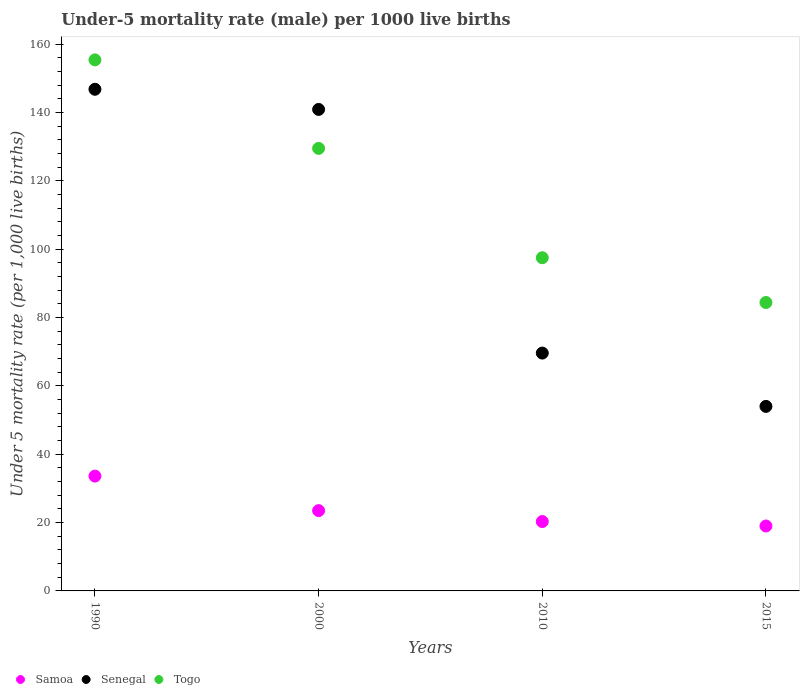What is the under-five mortality rate in Senegal in 2010?
Ensure brevity in your answer.  69.6. Across all years, what is the maximum under-five mortality rate in Senegal?
Give a very brief answer. 146.8. In which year was the under-five mortality rate in Togo maximum?
Your answer should be very brief. 1990. In which year was the under-five mortality rate in Senegal minimum?
Your answer should be very brief. 2015. What is the total under-five mortality rate in Togo in the graph?
Provide a short and direct response. 466.8. What is the difference between the under-five mortality rate in Samoa in 1990 and that in 2015?
Your answer should be compact. 14.6. What is the difference between the under-five mortality rate in Togo in 2015 and the under-five mortality rate in Samoa in 1990?
Keep it short and to the point. 50.8. What is the average under-five mortality rate in Togo per year?
Provide a succinct answer. 116.7. In the year 2010, what is the difference between the under-five mortality rate in Samoa and under-five mortality rate in Togo?
Your answer should be compact. -77.2. What is the ratio of the under-five mortality rate in Togo in 1990 to that in 2010?
Offer a terse response. 1.59. Is the difference between the under-five mortality rate in Samoa in 1990 and 2010 greater than the difference between the under-five mortality rate in Togo in 1990 and 2010?
Ensure brevity in your answer.  No. What is the difference between the highest and the second highest under-five mortality rate in Samoa?
Keep it short and to the point. 10.1. What is the difference between the highest and the lowest under-five mortality rate in Samoa?
Keep it short and to the point. 14.6. In how many years, is the under-five mortality rate in Samoa greater than the average under-five mortality rate in Samoa taken over all years?
Your answer should be compact. 1. Is the sum of the under-five mortality rate in Togo in 1990 and 2000 greater than the maximum under-five mortality rate in Senegal across all years?
Give a very brief answer. Yes. Is it the case that in every year, the sum of the under-five mortality rate in Senegal and under-five mortality rate in Samoa  is greater than the under-five mortality rate in Togo?
Provide a succinct answer. No. Does the under-five mortality rate in Samoa monotonically increase over the years?
Ensure brevity in your answer.  No. Is the under-five mortality rate in Samoa strictly greater than the under-five mortality rate in Senegal over the years?
Offer a very short reply. No. How many years are there in the graph?
Your response must be concise. 4. Does the graph contain any zero values?
Provide a succinct answer. No. Does the graph contain grids?
Offer a terse response. No. Where does the legend appear in the graph?
Make the answer very short. Bottom left. What is the title of the graph?
Provide a short and direct response. Under-5 mortality rate (male) per 1000 live births. Does "Ghana" appear as one of the legend labels in the graph?
Provide a succinct answer. No. What is the label or title of the X-axis?
Offer a very short reply. Years. What is the label or title of the Y-axis?
Offer a very short reply. Under 5 mortality rate (per 1,0 live births). What is the Under 5 mortality rate (per 1,000 live births) in Samoa in 1990?
Your answer should be very brief. 33.6. What is the Under 5 mortality rate (per 1,000 live births) of Senegal in 1990?
Ensure brevity in your answer.  146.8. What is the Under 5 mortality rate (per 1,000 live births) in Togo in 1990?
Your answer should be very brief. 155.4. What is the Under 5 mortality rate (per 1,000 live births) in Samoa in 2000?
Provide a short and direct response. 23.5. What is the Under 5 mortality rate (per 1,000 live births) of Senegal in 2000?
Your response must be concise. 140.9. What is the Under 5 mortality rate (per 1,000 live births) in Togo in 2000?
Provide a short and direct response. 129.5. What is the Under 5 mortality rate (per 1,000 live births) in Samoa in 2010?
Offer a terse response. 20.3. What is the Under 5 mortality rate (per 1,000 live births) of Senegal in 2010?
Make the answer very short. 69.6. What is the Under 5 mortality rate (per 1,000 live births) of Togo in 2010?
Your answer should be very brief. 97.5. What is the Under 5 mortality rate (per 1,000 live births) in Senegal in 2015?
Your answer should be compact. 54. What is the Under 5 mortality rate (per 1,000 live births) of Togo in 2015?
Your response must be concise. 84.4. Across all years, what is the maximum Under 5 mortality rate (per 1,000 live births) in Samoa?
Offer a very short reply. 33.6. Across all years, what is the maximum Under 5 mortality rate (per 1,000 live births) in Senegal?
Keep it short and to the point. 146.8. Across all years, what is the maximum Under 5 mortality rate (per 1,000 live births) of Togo?
Keep it short and to the point. 155.4. Across all years, what is the minimum Under 5 mortality rate (per 1,000 live births) of Togo?
Your answer should be very brief. 84.4. What is the total Under 5 mortality rate (per 1,000 live births) in Samoa in the graph?
Offer a terse response. 96.4. What is the total Under 5 mortality rate (per 1,000 live births) of Senegal in the graph?
Provide a succinct answer. 411.3. What is the total Under 5 mortality rate (per 1,000 live births) of Togo in the graph?
Offer a terse response. 466.8. What is the difference between the Under 5 mortality rate (per 1,000 live births) in Samoa in 1990 and that in 2000?
Provide a short and direct response. 10.1. What is the difference between the Under 5 mortality rate (per 1,000 live births) in Senegal in 1990 and that in 2000?
Your response must be concise. 5.9. What is the difference between the Under 5 mortality rate (per 1,000 live births) of Togo in 1990 and that in 2000?
Ensure brevity in your answer.  25.9. What is the difference between the Under 5 mortality rate (per 1,000 live births) in Senegal in 1990 and that in 2010?
Make the answer very short. 77.2. What is the difference between the Under 5 mortality rate (per 1,000 live births) of Togo in 1990 and that in 2010?
Give a very brief answer. 57.9. What is the difference between the Under 5 mortality rate (per 1,000 live births) in Samoa in 1990 and that in 2015?
Keep it short and to the point. 14.6. What is the difference between the Under 5 mortality rate (per 1,000 live births) in Senegal in 1990 and that in 2015?
Your answer should be compact. 92.8. What is the difference between the Under 5 mortality rate (per 1,000 live births) of Togo in 1990 and that in 2015?
Offer a very short reply. 71. What is the difference between the Under 5 mortality rate (per 1,000 live births) in Samoa in 2000 and that in 2010?
Keep it short and to the point. 3.2. What is the difference between the Under 5 mortality rate (per 1,000 live births) in Senegal in 2000 and that in 2010?
Your response must be concise. 71.3. What is the difference between the Under 5 mortality rate (per 1,000 live births) in Togo in 2000 and that in 2010?
Your answer should be very brief. 32. What is the difference between the Under 5 mortality rate (per 1,000 live births) of Samoa in 2000 and that in 2015?
Your answer should be compact. 4.5. What is the difference between the Under 5 mortality rate (per 1,000 live births) of Senegal in 2000 and that in 2015?
Give a very brief answer. 86.9. What is the difference between the Under 5 mortality rate (per 1,000 live births) in Togo in 2000 and that in 2015?
Keep it short and to the point. 45.1. What is the difference between the Under 5 mortality rate (per 1,000 live births) in Samoa in 2010 and that in 2015?
Provide a succinct answer. 1.3. What is the difference between the Under 5 mortality rate (per 1,000 live births) of Senegal in 2010 and that in 2015?
Keep it short and to the point. 15.6. What is the difference between the Under 5 mortality rate (per 1,000 live births) of Togo in 2010 and that in 2015?
Your answer should be compact. 13.1. What is the difference between the Under 5 mortality rate (per 1,000 live births) of Samoa in 1990 and the Under 5 mortality rate (per 1,000 live births) of Senegal in 2000?
Offer a very short reply. -107.3. What is the difference between the Under 5 mortality rate (per 1,000 live births) of Samoa in 1990 and the Under 5 mortality rate (per 1,000 live births) of Togo in 2000?
Your answer should be very brief. -95.9. What is the difference between the Under 5 mortality rate (per 1,000 live births) of Senegal in 1990 and the Under 5 mortality rate (per 1,000 live births) of Togo in 2000?
Offer a very short reply. 17.3. What is the difference between the Under 5 mortality rate (per 1,000 live births) of Samoa in 1990 and the Under 5 mortality rate (per 1,000 live births) of Senegal in 2010?
Provide a short and direct response. -36. What is the difference between the Under 5 mortality rate (per 1,000 live births) in Samoa in 1990 and the Under 5 mortality rate (per 1,000 live births) in Togo in 2010?
Your answer should be compact. -63.9. What is the difference between the Under 5 mortality rate (per 1,000 live births) of Senegal in 1990 and the Under 5 mortality rate (per 1,000 live births) of Togo in 2010?
Provide a short and direct response. 49.3. What is the difference between the Under 5 mortality rate (per 1,000 live births) of Samoa in 1990 and the Under 5 mortality rate (per 1,000 live births) of Senegal in 2015?
Ensure brevity in your answer.  -20.4. What is the difference between the Under 5 mortality rate (per 1,000 live births) of Samoa in 1990 and the Under 5 mortality rate (per 1,000 live births) of Togo in 2015?
Offer a very short reply. -50.8. What is the difference between the Under 5 mortality rate (per 1,000 live births) of Senegal in 1990 and the Under 5 mortality rate (per 1,000 live births) of Togo in 2015?
Your answer should be very brief. 62.4. What is the difference between the Under 5 mortality rate (per 1,000 live births) of Samoa in 2000 and the Under 5 mortality rate (per 1,000 live births) of Senegal in 2010?
Offer a very short reply. -46.1. What is the difference between the Under 5 mortality rate (per 1,000 live births) in Samoa in 2000 and the Under 5 mortality rate (per 1,000 live births) in Togo in 2010?
Your response must be concise. -74. What is the difference between the Under 5 mortality rate (per 1,000 live births) in Senegal in 2000 and the Under 5 mortality rate (per 1,000 live births) in Togo in 2010?
Offer a very short reply. 43.4. What is the difference between the Under 5 mortality rate (per 1,000 live births) of Samoa in 2000 and the Under 5 mortality rate (per 1,000 live births) of Senegal in 2015?
Provide a succinct answer. -30.5. What is the difference between the Under 5 mortality rate (per 1,000 live births) in Samoa in 2000 and the Under 5 mortality rate (per 1,000 live births) in Togo in 2015?
Your answer should be very brief. -60.9. What is the difference between the Under 5 mortality rate (per 1,000 live births) of Senegal in 2000 and the Under 5 mortality rate (per 1,000 live births) of Togo in 2015?
Ensure brevity in your answer.  56.5. What is the difference between the Under 5 mortality rate (per 1,000 live births) of Samoa in 2010 and the Under 5 mortality rate (per 1,000 live births) of Senegal in 2015?
Your answer should be very brief. -33.7. What is the difference between the Under 5 mortality rate (per 1,000 live births) in Samoa in 2010 and the Under 5 mortality rate (per 1,000 live births) in Togo in 2015?
Your answer should be compact. -64.1. What is the difference between the Under 5 mortality rate (per 1,000 live births) in Senegal in 2010 and the Under 5 mortality rate (per 1,000 live births) in Togo in 2015?
Keep it short and to the point. -14.8. What is the average Under 5 mortality rate (per 1,000 live births) of Samoa per year?
Offer a terse response. 24.1. What is the average Under 5 mortality rate (per 1,000 live births) in Senegal per year?
Ensure brevity in your answer.  102.83. What is the average Under 5 mortality rate (per 1,000 live births) of Togo per year?
Your response must be concise. 116.7. In the year 1990, what is the difference between the Under 5 mortality rate (per 1,000 live births) in Samoa and Under 5 mortality rate (per 1,000 live births) in Senegal?
Offer a terse response. -113.2. In the year 1990, what is the difference between the Under 5 mortality rate (per 1,000 live births) of Samoa and Under 5 mortality rate (per 1,000 live births) of Togo?
Provide a short and direct response. -121.8. In the year 1990, what is the difference between the Under 5 mortality rate (per 1,000 live births) of Senegal and Under 5 mortality rate (per 1,000 live births) of Togo?
Your answer should be very brief. -8.6. In the year 2000, what is the difference between the Under 5 mortality rate (per 1,000 live births) in Samoa and Under 5 mortality rate (per 1,000 live births) in Senegal?
Offer a very short reply. -117.4. In the year 2000, what is the difference between the Under 5 mortality rate (per 1,000 live births) of Samoa and Under 5 mortality rate (per 1,000 live births) of Togo?
Your answer should be compact. -106. In the year 2000, what is the difference between the Under 5 mortality rate (per 1,000 live births) of Senegal and Under 5 mortality rate (per 1,000 live births) of Togo?
Offer a very short reply. 11.4. In the year 2010, what is the difference between the Under 5 mortality rate (per 1,000 live births) in Samoa and Under 5 mortality rate (per 1,000 live births) in Senegal?
Provide a short and direct response. -49.3. In the year 2010, what is the difference between the Under 5 mortality rate (per 1,000 live births) of Samoa and Under 5 mortality rate (per 1,000 live births) of Togo?
Your answer should be very brief. -77.2. In the year 2010, what is the difference between the Under 5 mortality rate (per 1,000 live births) in Senegal and Under 5 mortality rate (per 1,000 live births) in Togo?
Ensure brevity in your answer.  -27.9. In the year 2015, what is the difference between the Under 5 mortality rate (per 1,000 live births) of Samoa and Under 5 mortality rate (per 1,000 live births) of Senegal?
Offer a terse response. -35. In the year 2015, what is the difference between the Under 5 mortality rate (per 1,000 live births) in Samoa and Under 5 mortality rate (per 1,000 live births) in Togo?
Your response must be concise. -65.4. In the year 2015, what is the difference between the Under 5 mortality rate (per 1,000 live births) in Senegal and Under 5 mortality rate (per 1,000 live births) in Togo?
Your answer should be compact. -30.4. What is the ratio of the Under 5 mortality rate (per 1,000 live births) of Samoa in 1990 to that in 2000?
Your answer should be very brief. 1.43. What is the ratio of the Under 5 mortality rate (per 1,000 live births) in Senegal in 1990 to that in 2000?
Ensure brevity in your answer.  1.04. What is the ratio of the Under 5 mortality rate (per 1,000 live births) in Togo in 1990 to that in 2000?
Your answer should be compact. 1.2. What is the ratio of the Under 5 mortality rate (per 1,000 live births) of Samoa in 1990 to that in 2010?
Keep it short and to the point. 1.66. What is the ratio of the Under 5 mortality rate (per 1,000 live births) in Senegal in 1990 to that in 2010?
Make the answer very short. 2.11. What is the ratio of the Under 5 mortality rate (per 1,000 live births) in Togo in 1990 to that in 2010?
Your response must be concise. 1.59. What is the ratio of the Under 5 mortality rate (per 1,000 live births) of Samoa in 1990 to that in 2015?
Ensure brevity in your answer.  1.77. What is the ratio of the Under 5 mortality rate (per 1,000 live births) in Senegal in 1990 to that in 2015?
Offer a very short reply. 2.72. What is the ratio of the Under 5 mortality rate (per 1,000 live births) in Togo in 1990 to that in 2015?
Offer a very short reply. 1.84. What is the ratio of the Under 5 mortality rate (per 1,000 live births) in Samoa in 2000 to that in 2010?
Ensure brevity in your answer.  1.16. What is the ratio of the Under 5 mortality rate (per 1,000 live births) in Senegal in 2000 to that in 2010?
Provide a succinct answer. 2.02. What is the ratio of the Under 5 mortality rate (per 1,000 live births) of Togo in 2000 to that in 2010?
Give a very brief answer. 1.33. What is the ratio of the Under 5 mortality rate (per 1,000 live births) of Samoa in 2000 to that in 2015?
Ensure brevity in your answer.  1.24. What is the ratio of the Under 5 mortality rate (per 1,000 live births) of Senegal in 2000 to that in 2015?
Your response must be concise. 2.61. What is the ratio of the Under 5 mortality rate (per 1,000 live births) in Togo in 2000 to that in 2015?
Ensure brevity in your answer.  1.53. What is the ratio of the Under 5 mortality rate (per 1,000 live births) of Samoa in 2010 to that in 2015?
Your answer should be very brief. 1.07. What is the ratio of the Under 5 mortality rate (per 1,000 live births) in Senegal in 2010 to that in 2015?
Offer a very short reply. 1.29. What is the ratio of the Under 5 mortality rate (per 1,000 live births) of Togo in 2010 to that in 2015?
Provide a short and direct response. 1.16. What is the difference between the highest and the second highest Under 5 mortality rate (per 1,000 live births) of Togo?
Offer a very short reply. 25.9. What is the difference between the highest and the lowest Under 5 mortality rate (per 1,000 live births) of Senegal?
Give a very brief answer. 92.8. 